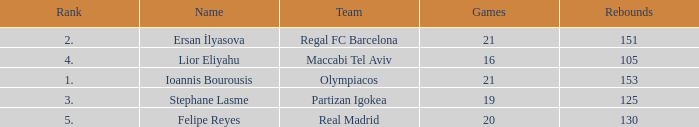What rank is Partizan Igokea that has less than 130 rebounds? 3.0. 